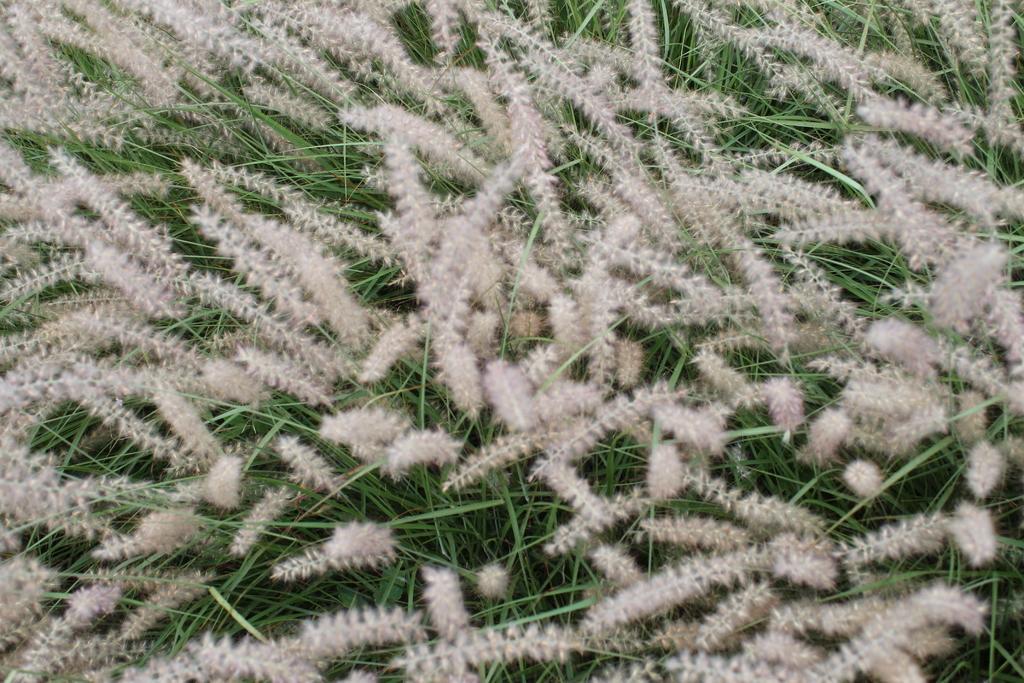Could you give a brief overview of what you see in this image? In this picture I can see flowers. 